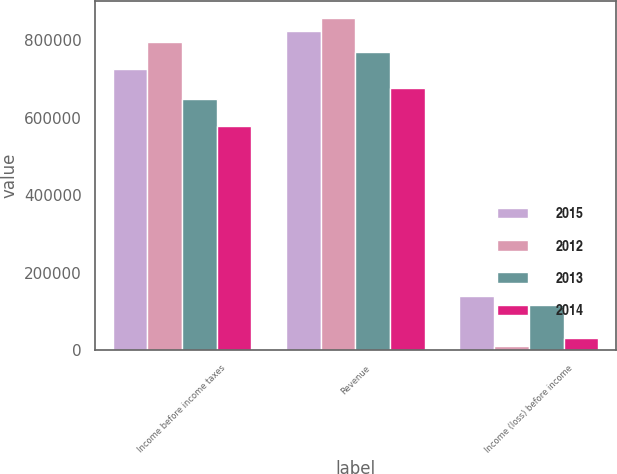Convert chart to OTSL. <chart><loc_0><loc_0><loc_500><loc_500><stacked_bar_chart><ecel><fcel>Income before income taxes<fcel>Revenue<fcel>Income (loss) before income<nl><fcel>2015<fcel>724667<fcel>823663<fcel>139415<nl><fcel>2012<fcel>796309<fcel>857782<fcel>10431<nl><fcel>2013<fcel>648740<fcel>770190<fcel>117199<nl><fcel>2014<fcel>578500<fcel>677637<fcel>31901<nl></chart> 